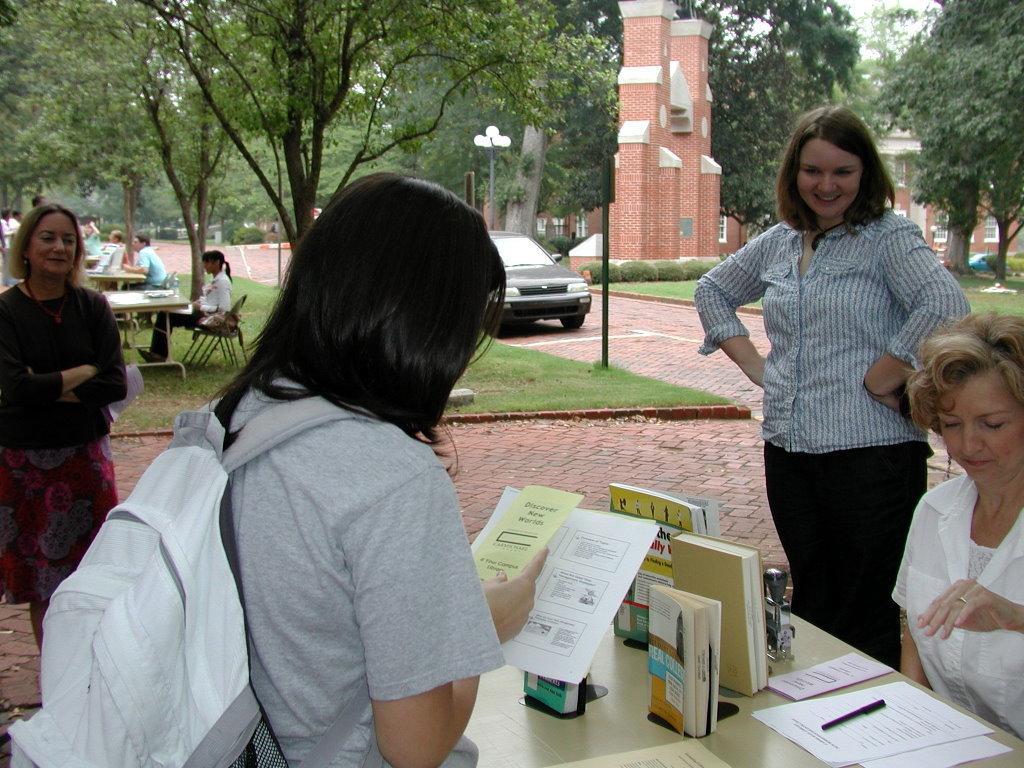Describe this image in one or two sentences. On the right side of the image we can see a lady sitting, next to her there is another lady standing before them there is a table and we can see books, paper and a pen placed on the table. On the left there are two ladies standing. In the background there are tables and chairs and we can see people sitting there is a car, trees, pole, pillars and grass. 